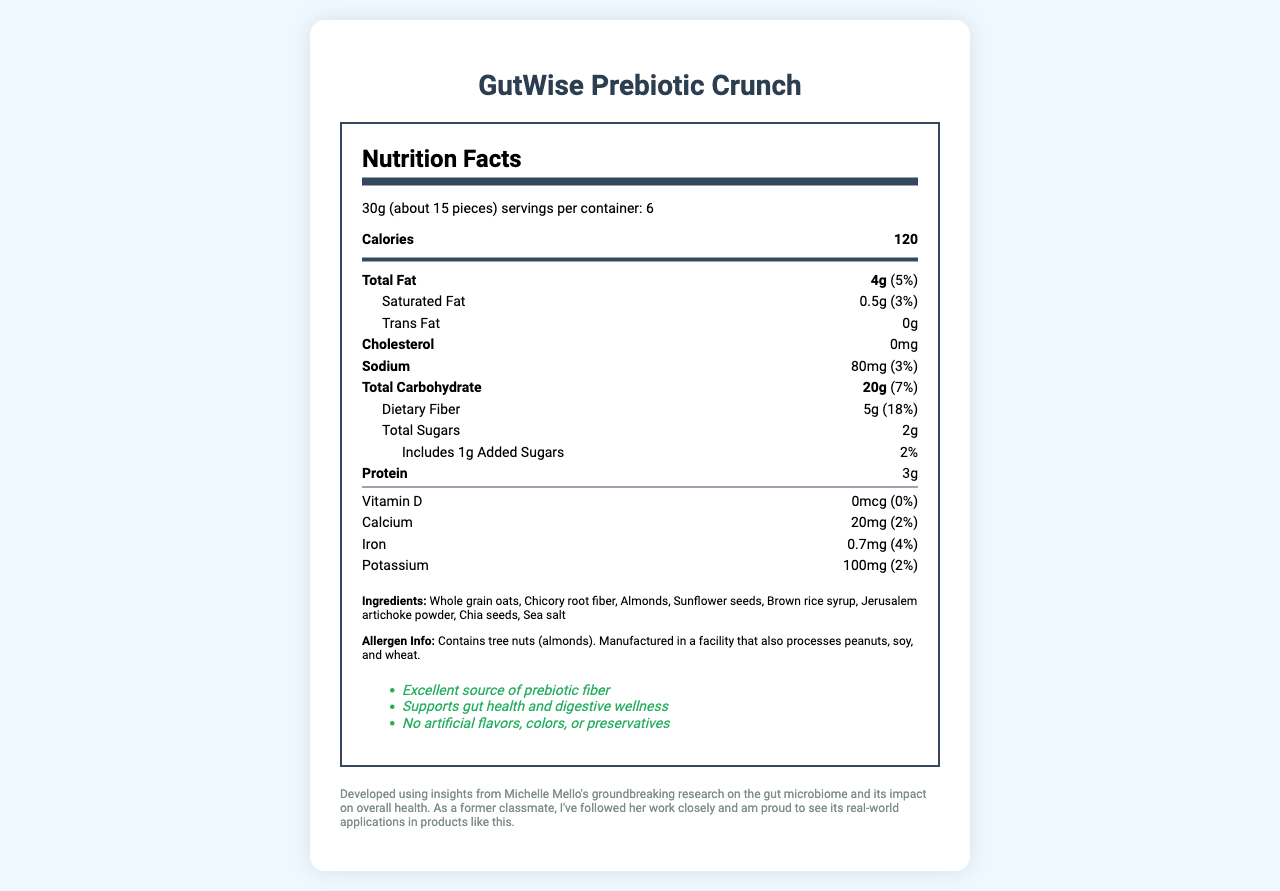what is the product's name? The name of the product is mentioned at the top of the document and is displayed prominently.
Answer: GutWise Prebiotic Crunch what is the serving size of this product? The serving size is listed in the document under the nutrition facts section: "30g (about 15 pieces)".
Answer: 30g (about 15 pieces) how many calories are in one serving? The document states that there are 120 calories per serving.
Answer: 120 which ingredient provides prebiotic fiber? Chicory root fiber is known for its prebiotic properties and is listed in the ingredients section.
Answer: Chicory root fiber how much dietary fiber does one serving contain? The amount of dietary fiber is mentioned under the nutritional information: "Dietary Fiber: 5g".
Answer: 5g how many servings are in one container? The document specifies that there are 6 servings per container.
Answer: 6 how much protein is in the product per serving? The protein content per serving is listed as 3g in the nutrition information.
Answer: 3g how much added sugar is in one serving? The document indicates 1g of added sugars per serving.
Answer: 1g What can you infer about the product based on the allergen information? A. It is allergen-free B. It contains gluten C. It contains tree nuts The allergen information states that the product contains tree nuts (almonds).
Answer: C which of the following vitamins or minerals has the highest daily value percentage in this product? A. Vitamin D B. Calcium C. Iron Iron has the highest daily value percentage among the listed options at 4%.
Answer: C are there any artificial flavors in this product? The health claims explicitly state "No artificial flavors, colors, or preservatives".
Answer: No is this product an excellent source of prebiotic fiber? One of the health claims on the document declares that it is an "excellent source of prebiotic fiber".
Answer: Yes summarize the key nutritional attributes and health benefits of this product. The summary highlights the nutritional values, health claims, and the primary attribute of supporting gut health.
Answer: GutWise Prebiotic Crunch is a prebiotic snack that supports gut health and digestive wellness. Each serving provides 120 calories, 4g of total fat, 5g of dietary fiber, 3g of protein, and small amounts of several vitamins and minerals. The product is free of artificial flavors, colors, and preservatives and contains 1g of added sugars. It's suitable for those concerned about gut health due to its prebiotic fiber content from ingredients like chicory root fiber. where is the product manufactured? The document does not provide specific information regarding the manufacturing location.
Answer: Cannot be determined how should this product be stored for optimal freshness? The storage instructions are given at the end of the document.
Answer: Store in a cool, dry place. Consume within 30 days of opening. which ingredient is used as a sweetener in the product? Brown rice syrup is listed among the ingredients and is known for its sweetening properties.
Answer: Brown rice syrup how much saturated fat is in one serving? The nutrition facts indicate that there are 0.5g of saturated fat per serving.
Answer: 0.5g what is the connection to Michelle Mello's research? The document mentions that the product "was developed using insights from Michelle Mello's groundbreaking research on the gut microbiome."
Answer: The product was developed using insights from Michelle Mello's research on the gut microbiome and its impact on overall health. 